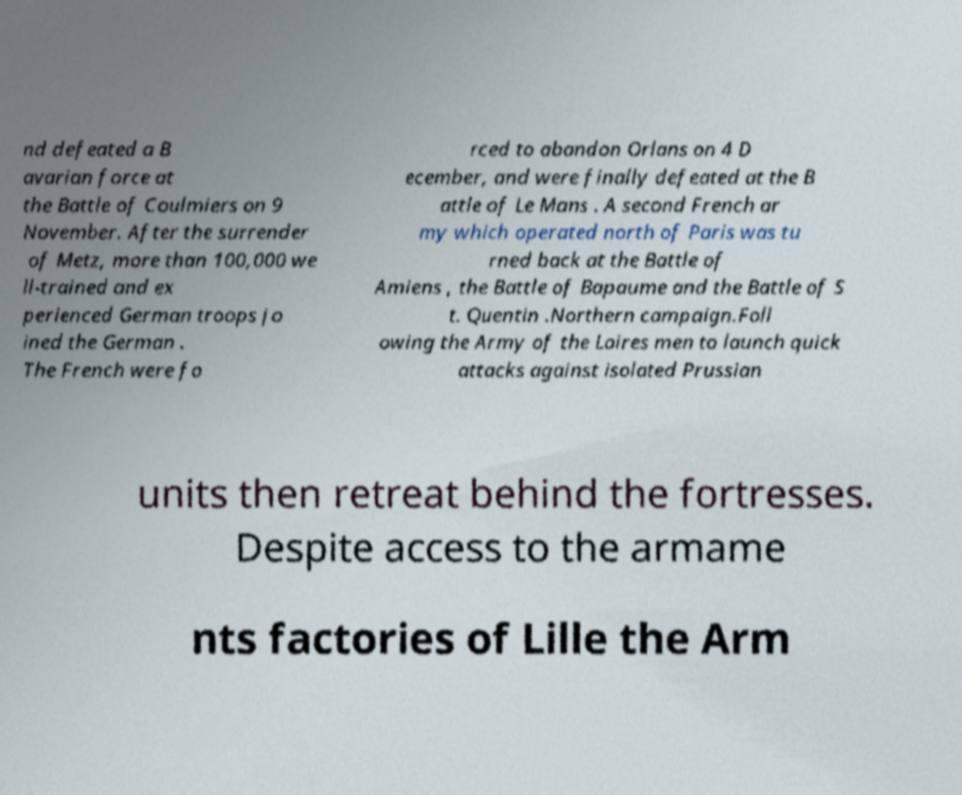Can you read and provide the text displayed in the image?This photo seems to have some interesting text. Can you extract and type it out for me? nd defeated a B avarian force at the Battle of Coulmiers on 9 November. After the surrender of Metz, more than 100,000 we ll-trained and ex perienced German troops jo ined the German . The French were fo rced to abandon Orlans on 4 D ecember, and were finally defeated at the B attle of Le Mans . A second French ar my which operated north of Paris was tu rned back at the Battle of Amiens , the Battle of Bapaume and the Battle of S t. Quentin .Northern campaign.Foll owing the Army of the Loires men to launch quick attacks against isolated Prussian units then retreat behind the fortresses. Despite access to the armame nts factories of Lille the Arm 